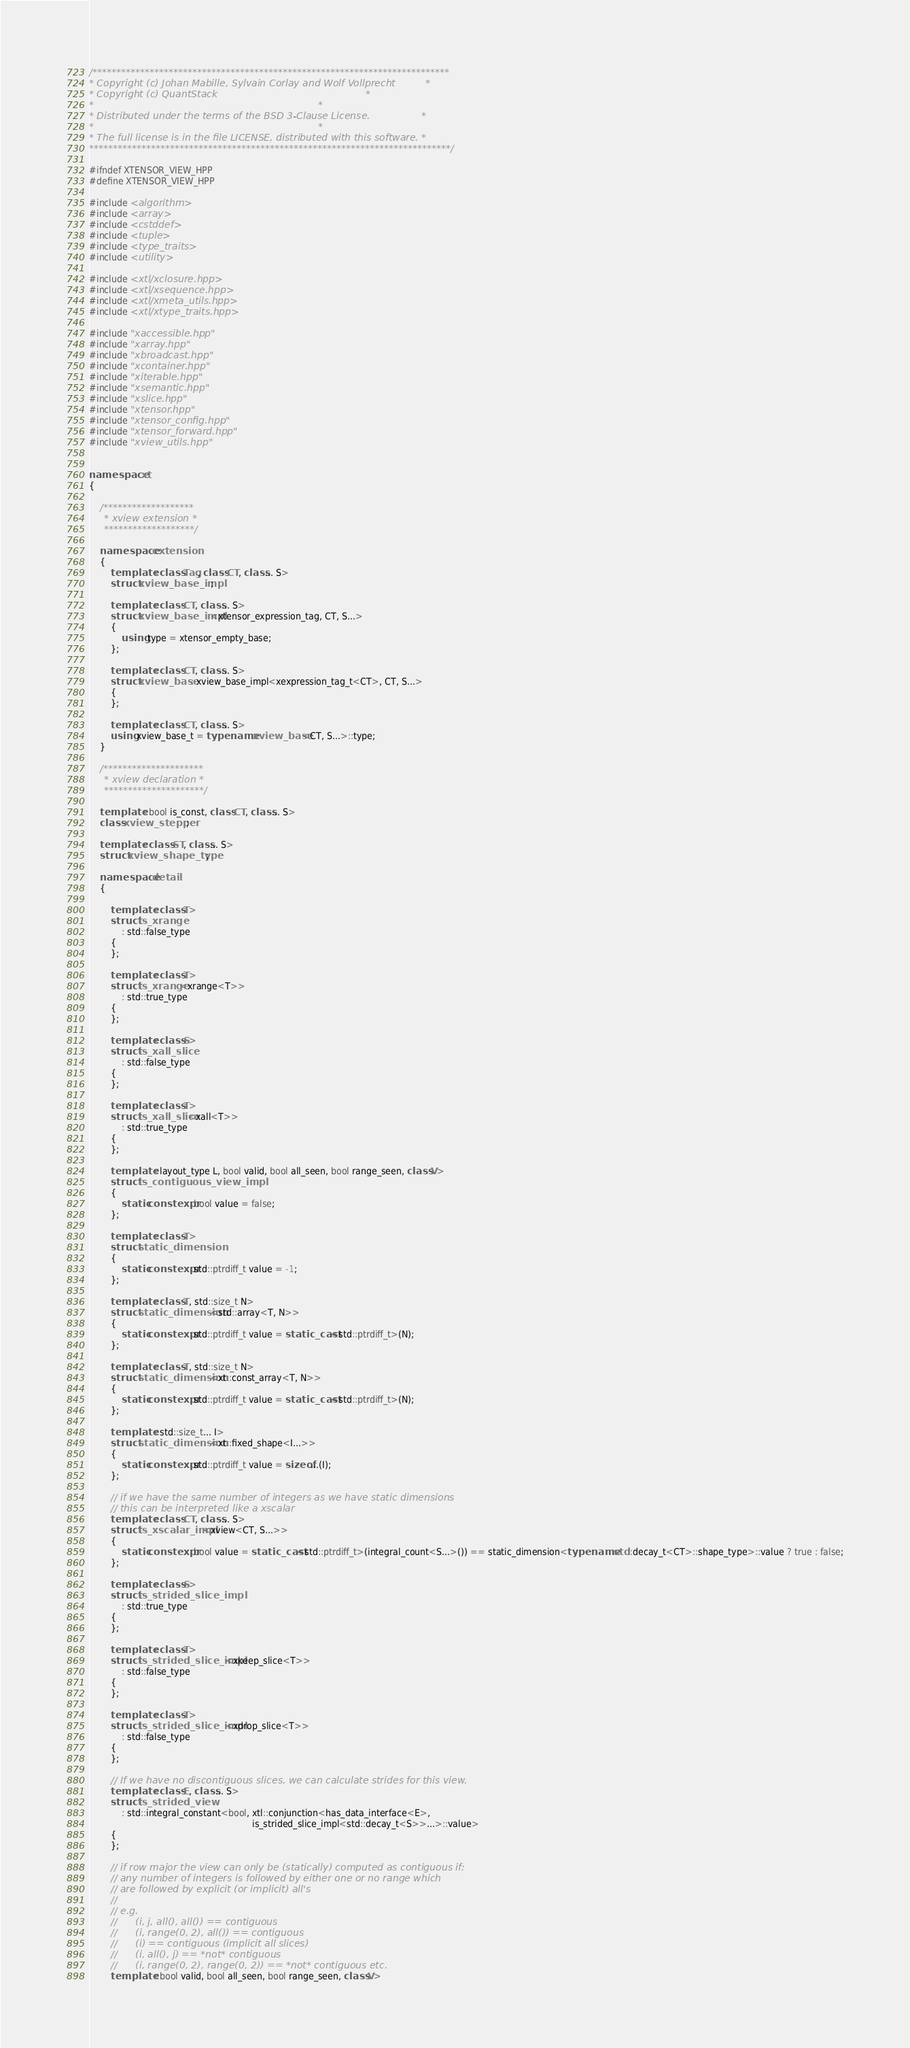<code> <loc_0><loc_0><loc_500><loc_500><_C++_>/***************************************************************************
* Copyright (c) Johan Mabille, Sylvain Corlay and Wolf Vollprecht          *
* Copyright (c) QuantStack                                                 *
*                                                                          *
* Distributed under the terms of the BSD 3-Clause License.                 *
*                                                                          *
* The full license is in the file LICENSE, distributed with this software. *
****************************************************************************/

#ifndef XTENSOR_VIEW_HPP
#define XTENSOR_VIEW_HPP

#include <algorithm>
#include <array>
#include <cstddef>
#include <tuple>
#include <type_traits>
#include <utility>

#include <xtl/xclosure.hpp>
#include <xtl/xsequence.hpp>
#include <xtl/xmeta_utils.hpp>
#include <xtl/xtype_traits.hpp>

#include "xaccessible.hpp"
#include "xarray.hpp"
#include "xbroadcast.hpp"
#include "xcontainer.hpp"
#include "xiterable.hpp"
#include "xsemantic.hpp"
#include "xslice.hpp"
#include "xtensor.hpp"
#include "xtensor_config.hpp"
#include "xtensor_forward.hpp"
#include "xview_utils.hpp"


namespace xt
{

    /*******************
     * xview extension *
     *******************/

    namespace extension
    {
        template <class Tag, class CT, class... S>
        struct xview_base_impl;

        template <class CT, class... S>
        struct xview_base_impl<xtensor_expression_tag, CT, S...>
        {
            using type = xtensor_empty_base;
        };

        template <class CT, class... S>
        struct xview_base : xview_base_impl<xexpression_tag_t<CT>, CT, S...>
        {
        };

        template <class CT, class... S>
        using xview_base_t = typename xview_base<CT, S...>::type;
    }

    /*********************
     * xview declaration *
     *********************/

    template <bool is_const, class CT, class... S>
    class xview_stepper;

    template <class ST, class... S>
    struct xview_shape_type;

    namespace detail
    {

        template <class T>
        struct is_xrange
            : std::false_type
        {
        };

        template <class T>
        struct is_xrange<xrange<T>>
            : std::true_type
        {
        };

        template <class S>
        struct is_xall_slice
            : std::false_type
        {
        };

        template <class T>
        struct is_xall_slice<xall<T>>
            : std::true_type
        {
        };

        template <layout_type L, bool valid, bool all_seen, bool range_seen, class V>
        struct is_contiguous_view_impl
        {
            static constexpr bool value = false;
        };

        template <class T>
        struct static_dimension
        {
            static constexpr std::ptrdiff_t value = -1;
        };

        template <class T, std::size_t N>
        struct static_dimension<std::array<T, N>>
        {
            static constexpr std::ptrdiff_t value = static_cast<std::ptrdiff_t>(N);
        };

        template <class T, std::size_t N>
        struct static_dimension<xt::const_array<T, N>>
        {
            static constexpr std::ptrdiff_t value = static_cast<std::ptrdiff_t>(N);
        };

        template <std::size_t... I>
        struct static_dimension<xt::fixed_shape<I...>>
        {
            static constexpr std::ptrdiff_t value = sizeof...(I);
        };

        // if we have the same number of integers as we have static dimensions
        // this can be interpreted like a xscalar
        template <class CT, class... S>
        struct is_xscalar_impl<xview<CT, S...>>
        {
            static constexpr bool value = static_cast<std::ptrdiff_t>(integral_count<S...>()) == static_dimension<typename std::decay_t<CT>::shape_type>::value ? true : false;
        };

        template <class S>
        struct is_strided_slice_impl
            : std::true_type
        {
        };

        template <class T>
        struct is_strided_slice_impl<xkeep_slice<T>>
            : std::false_type
        {
        };

        template <class T>
        struct is_strided_slice_impl<xdrop_slice<T>>
            : std::false_type
        {
        };

        // If we have no discontiguous slices, we can calculate strides for this view.
        template <class E, class... S>
        struct is_strided_view
            : std::integral_constant<bool, xtl::conjunction<has_data_interface<E>,
                                                            is_strided_slice_impl<std::decay_t<S>>...>::value>
        {
        };

        // if row major the view can only be (statically) computed as contiguous if:
        // any number of integers is followed by either one or no range which
        // are followed by explicit (or implicit) all's
        //
        // e.g.
        //      (i, j, all(), all()) == contiguous
        //      (i, range(0, 2), all()) == contiguous
        //      (i) == contiguous (implicit all slices)
        //      (i, all(), j) == *not* contiguous
        //      (i, range(0, 2), range(0, 2)) == *not* contiguous etc.
        template <bool valid, bool all_seen, bool range_seen, class V></code> 